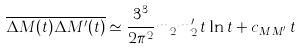Convert formula to latex. <formula><loc_0><loc_0><loc_500><loc_500>\overline { \Delta M ( t ) \Delta M ^ { \prime } ( t ) } \simeq \frac { 3 ^ { 3 } } { 2 \pi ^ { 2 } } m _ { 2 } m _ { 2 } ^ { \prime } \, t \ln t + c _ { M M ^ { \prime } } \, t</formula> 